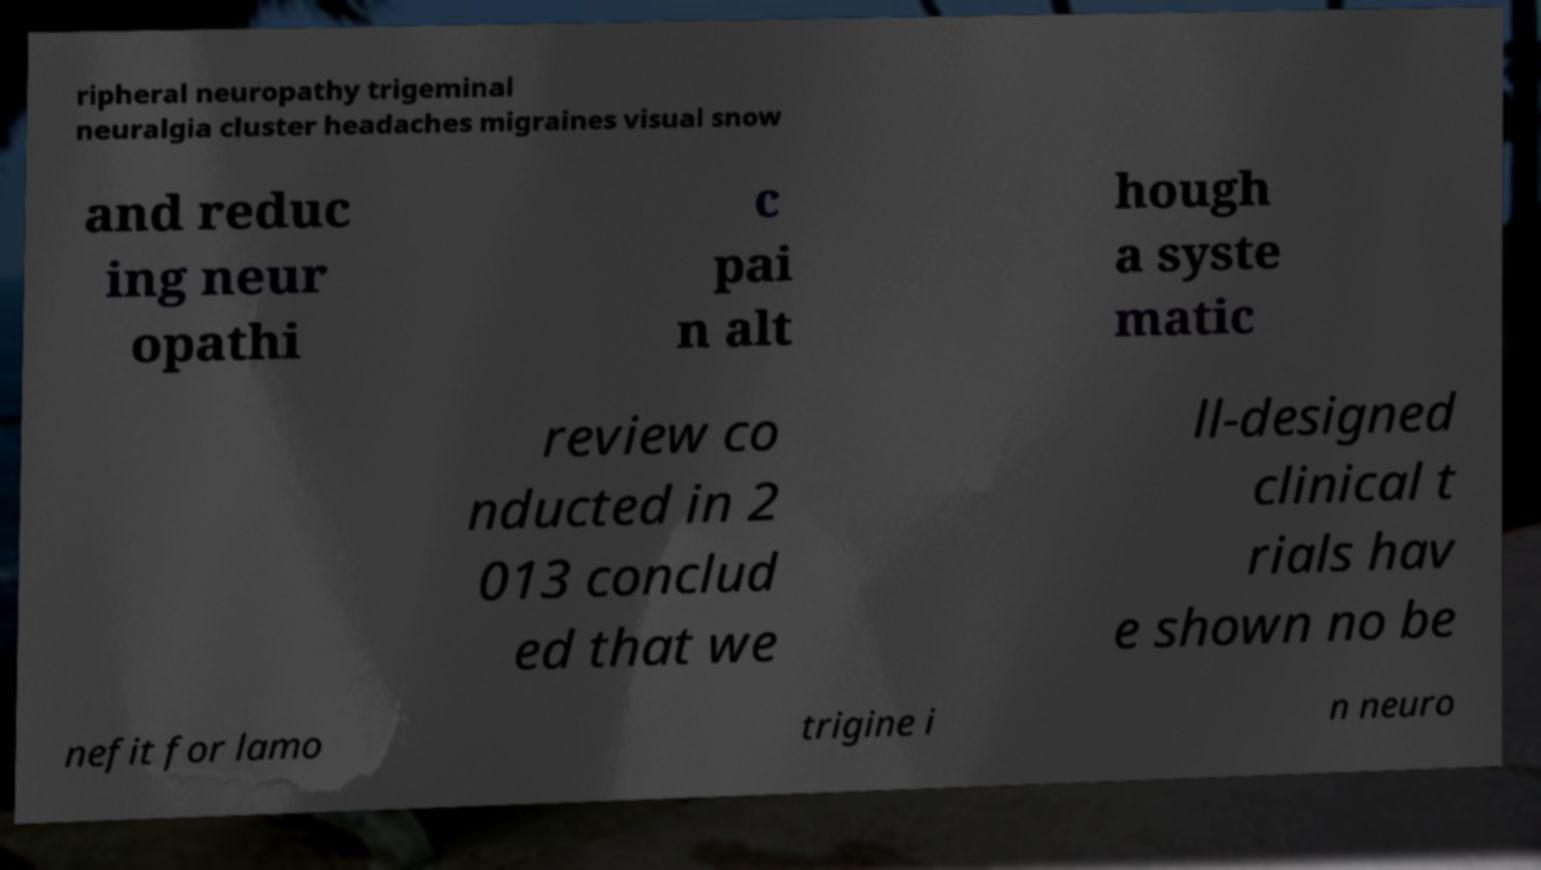For documentation purposes, I need the text within this image transcribed. Could you provide that? ripheral neuropathy trigeminal neuralgia cluster headaches migraines visual snow and reduc ing neur opathi c pai n alt hough a syste matic review co nducted in 2 013 conclud ed that we ll-designed clinical t rials hav e shown no be nefit for lamo trigine i n neuro 